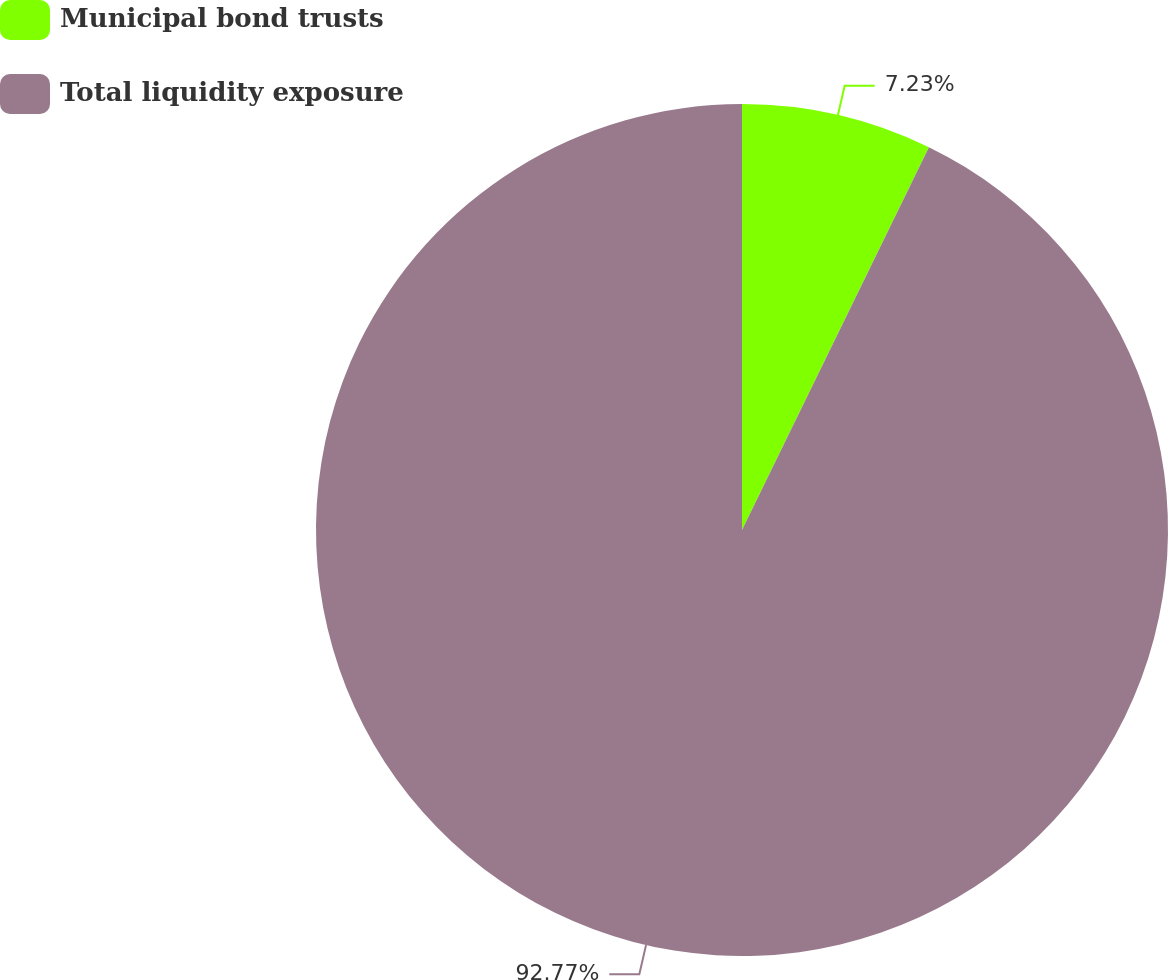Convert chart. <chart><loc_0><loc_0><loc_500><loc_500><pie_chart><fcel>Municipal bond trusts<fcel>Total liquidity exposure<nl><fcel>7.23%<fcel>92.77%<nl></chart> 